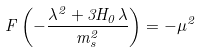Convert formula to latex. <formula><loc_0><loc_0><loc_500><loc_500>F \left ( - \frac { \lambda ^ { 2 } + 3 H _ { 0 } \lambda } { m _ { s } ^ { 2 } } \right ) = - \mu ^ { 2 }</formula> 